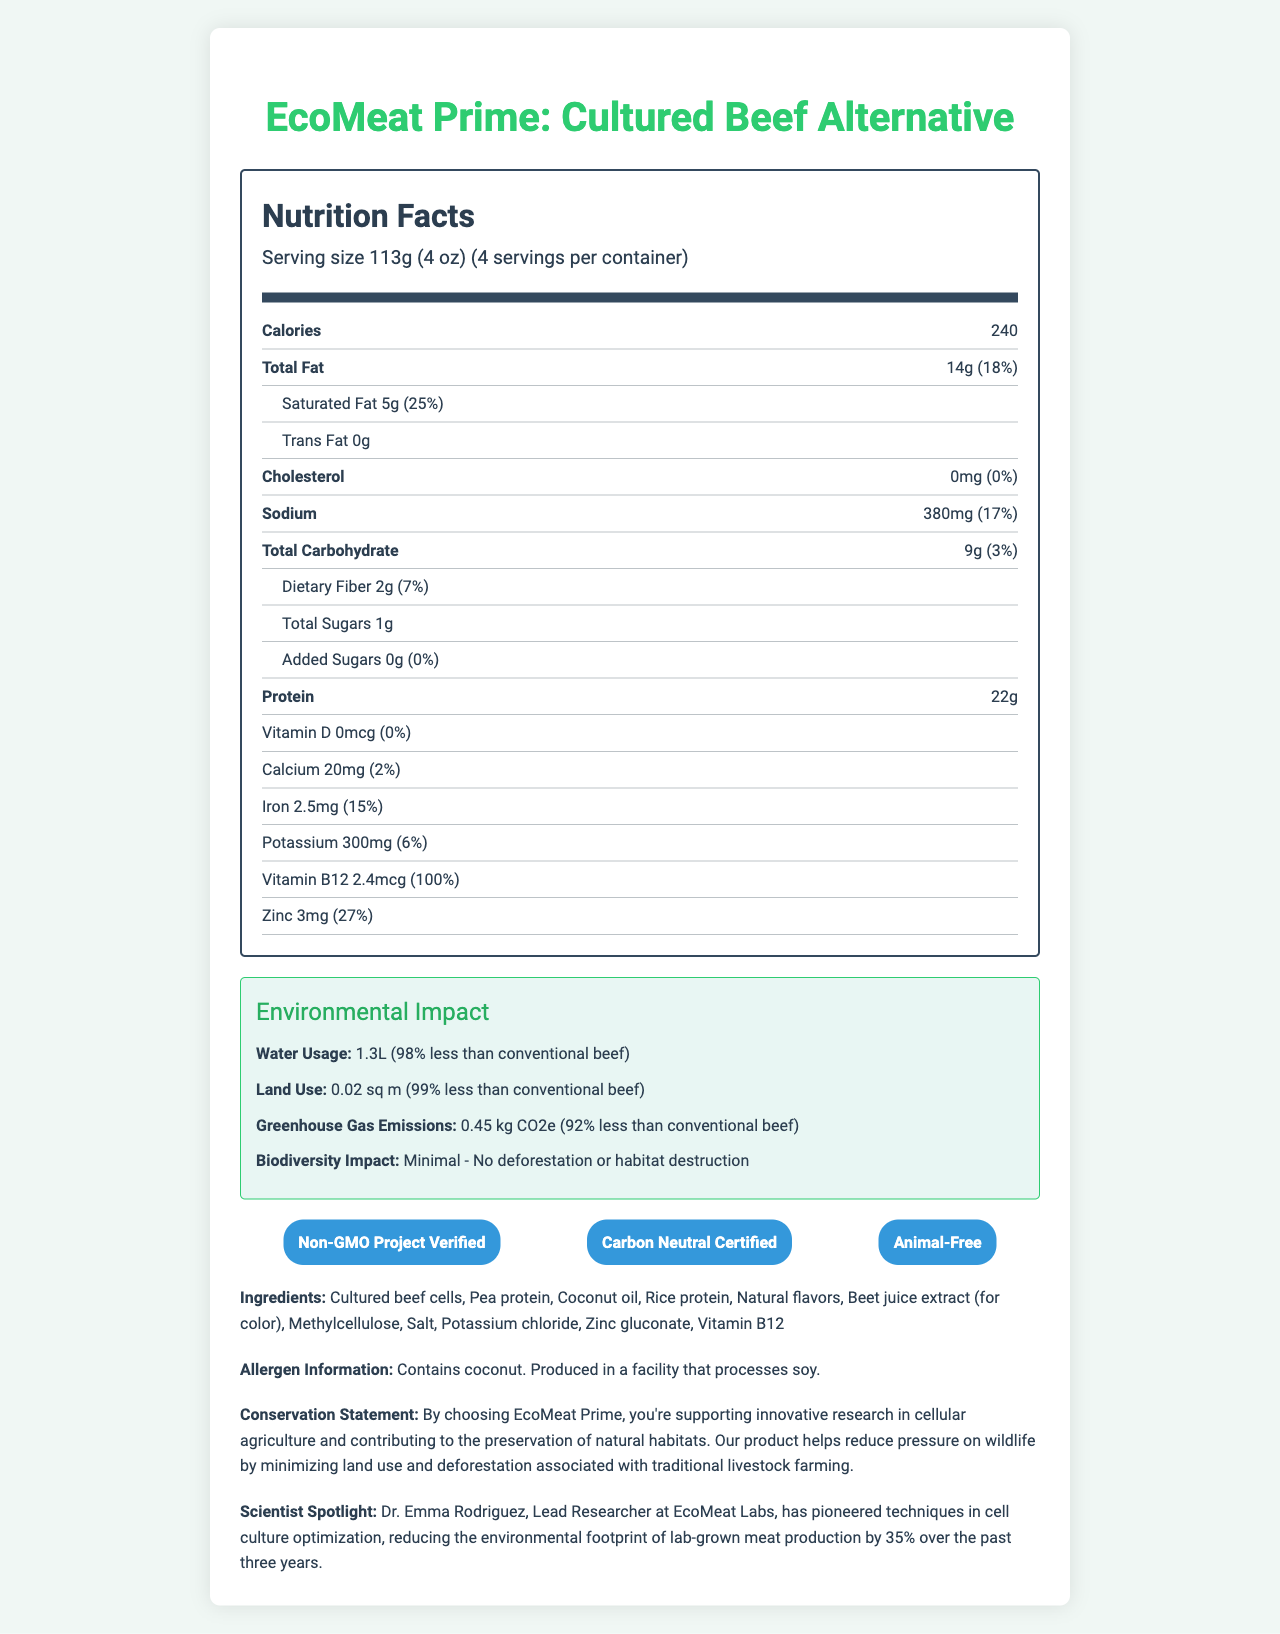What is the serving size of EcoMeat Prime? The serving size is listed as "113g (4 oz)" in the nutrition facts section.
Answer: 113g (4 oz) How many servings are there per container? The document indicates that there are 4 servings per container.
Answer: 4 What is the amount of total fat per serving? The total fat content per serving is indicated as "14g" in the nutrition facts section.
Answer: 14g How much protein is in one serving of EcoMeat Prime? The protein content per serving is listed as "22g" in the nutrition facts section.
Answer: 22g What certifications does EcoMeat Prime have? The certifications listed in the document are "Non-GMO Project Verified," "Carbon Neutral Certified," and "Animal-Free."
Answer: Non-GMO Project Verified, Carbon Neutral Certified, Animal-Free How much water is used to produce EcoMeat Prime compared to conventional beef? A. 50% less B. 75% less C. 98% less D. 99% less The environmental impact section indicates that the water usage for EcoMeat Prime is 1.3L, which is 98% less than conventional beef.
Answer: C. 98% less What is the daily value percentage of saturated fat per serving? A. 10% B. 18% C. 25% D. 30% The daily value percentage for saturated fat is listed as 25% in the nutrition facts section.
Answer: C. 25% Does EcoMeat Prime contain any added sugars? The document shows that the amount of added sugars is 0g, indicating there are no added sugars.
Answer: No Is EcoMeat Prime produced in a facility that processes soy? The allergen information states that it is produced in a facility that processes soy.
Answer: Yes What ingredient is used for color in EcoMeat Prime? The ingredients list indicates that beet juice extract is used for color.
Answer: Beet juice extract What can you infer about the environmental impact of EcoMeat Prime based on the provided data? The environmental impact section details reduced water usage (98% less), land use (99% less), and greenhouse gas emissions (92% less), along with a minimal biodiversity impact, indicating no deforestation or habitat destruction.
Answer: EcoMeat Prime has a significantly reduced environmental impact compared to conventional beef, with lower water and land use, reduced greenhouse gas emissions, and minimal biodiversity impact. Who is highlighted in the Scientist Spotlight section? The document's Scientist Spotlight mentions Dr. Emma Rodriguez as the lead researcher at EcoMeat Labs.
Answer: Dr. Emma Rodriguez Describe the main purpose and information provided in the document. The main purpose of the document is to inform consumers about the nutritional value, environmental benefits, and other relevant details about EcoMeat Prime to encourage informed purchasing decisions.
Answer: The document provides detailed nutrition facts, environmental impact data, certifications, ingredients, allergen information, conservation statements, and a spotlight on a leading scientist for the lab-grown meat alternative "EcoMeat Prime: Cultured Beef Alternative." What is the cholesterol content of EcoMeat Prime? The nutrition facts section indicates that the cholesterol content per serving is 0mg.
Answer: 0mg What daily value percentage of vitamin B12 does each serving of EcoMeat Prime provide? The vitamin B12 content per serving is listed as 2.4mcg, which provides 100% of the daily value.
Answer: 100% What percentage of the daily value of iron does one serving of EcoMeat Prime contain? The daily value percentage for iron is indicated as 15% in the nutrition facts section.
Answer: 15% How much greenhouse gas emissions does EcoMeat Prime generate compared to conventional beef? The document states that EcoMeat Prime produces 0.45 kg CO2e of greenhouse gas emissions, which is 92% less than conventional beef.
Answer: 0.45 kg CO2e, 92% less than conventional beef What flavoring agent is used in EcoMeat Prime? The ingredients list includes "Natural flavors" as one of the ingredients.
Answer: Natural flavors What is the main critique of traditional livestock farming that EcoMeat Prime aims to address? The conservation statement indicates that EcoMeat Prime helps reduce pressure on wildlife by minimizing land use and deforestation associated with traditional livestock farming.
Answer: Minimizing land use and deforestation What facility type does EcoMeat Prime's production include, according to the information provided? The document does not specify the type of facility used for producing EcoMeat Prime, only that it is produced in a facility that processes soy.
Answer: Cannot be determined 